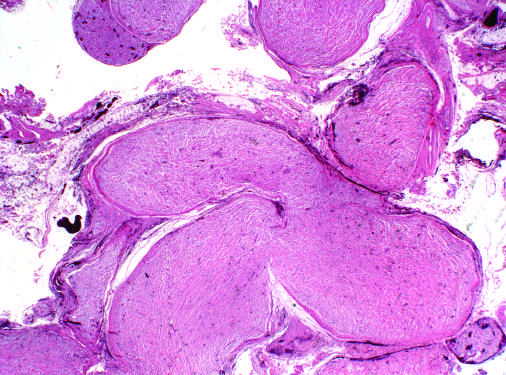what are multiple nerve fascicles expanded by?
Answer the question using a single word or phrase. Infiltrating tumor cells 